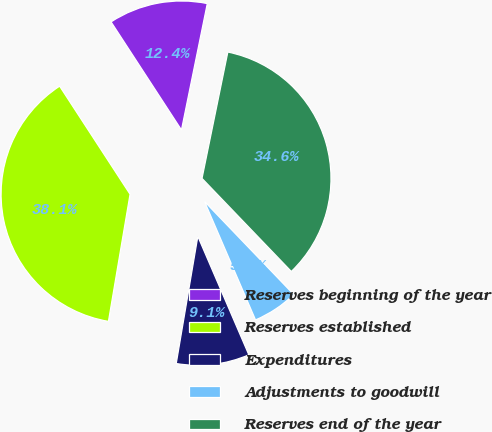<chart> <loc_0><loc_0><loc_500><loc_500><pie_chart><fcel>Reserves beginning of the year<fcel>Reserves established<fcel>Expenditures<fcel>Adjustments to goodwill<fcel>Reserves end of the year<nl><fcel>12.4%<fcel>38.13%<fcel>9.15%<fcel>5.7%<fcel>34.62%<nl></chart> 